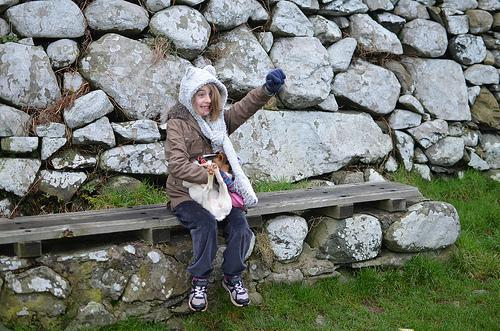Question: what color is the grass?
Choices:
A. Yellow.
B. Brown.
C. Green.
D. Black.
Answer with the letter. Answer: C Question: what color are the rocks?
Choices:
A. Gray.
B. White.
C. Brown.
D. White and gray.
Answer with the letter. Answer: D Question: what is the girl sitting on?
Choices:
A. A couch.
B. A chair.
C. A bed.
D. The bench.
Answer with the letter. Answer: D Question: who is sitting on the bench?
Choices:
A. The girl.
B. The boy.
C. A child.
D. A shopper.
Answer with the letter. Answer: A Question: where was the picture taken?
Choices:
A. By the beach.
B. On the street.
C. Near a rocky wall.
D. In the sand.
Answer with the letter. Answer: C 